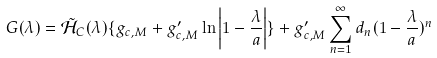Convert formula to latex. <formula><loc_0><loc_0><loc_500><loc_500>G ( \lambda ) = \tilde { \mathcal { H } } _ { C } ( \lambda ) \{ g _ { c , M } + g _ { c , M } ^ { \prime } \ln \left | 1 - \frac { \lambda } { a } \right | \} + g _ { c , M } ^ { \prime } \sum _ { n = 1 } ^ { \infty } d _ { n } ( 1 - \frac { \lambda } { a } ) ^ { n }</formula> 